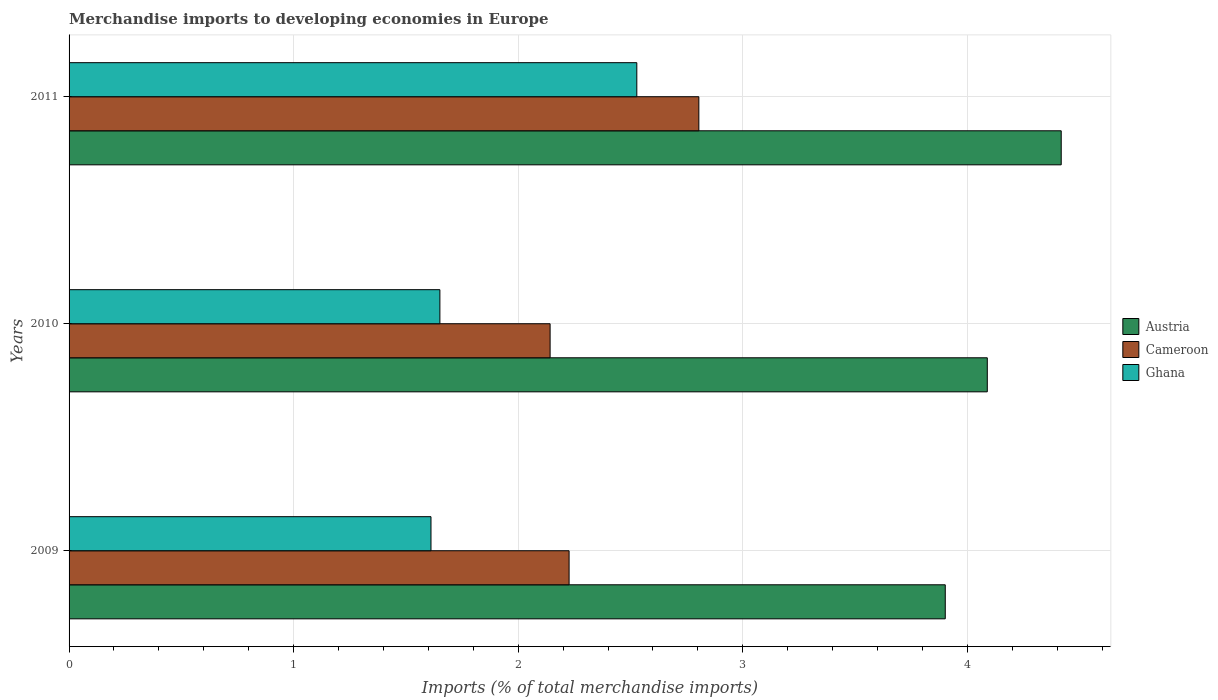How many groups of bars are there?
Provide a succinct answer. 3. Are the number of bars per tick equal to the number of legend labels?
Your answer should be compact. Yes. Are the number of bars on each tick of the Y-axis equal?
Give a very brief answer. Yes. How many bars are there on the 3rd tick from the top?
Your response must be concise. 3. How many bars are there on the 2nd tick from the bottom?
Provide a short and direct response. 3. In how many cases, is the number of bars for a given year not equal to the number of legend labels?
Provide a succinct answer. 0. What is the percentage total merchandise imports in Ghana in 2010?
Make the answer very short. 1.65. Across all years, what is the maximum percentage total merchandise imports in Austria?
Your answer should be compact. 4.42. Across all years, what is the minimum percentage total merchandise imports in Cameroon?
Give a very brief answer. 2.14. In which year was the percentage total merchandise imports in Ghana minimum?
Offer a terse response. 2009. What is the total percentage total merchandise imports in Cameroon in the graph?
Your response must be concise. 7.17. What is the difference between the percentage total merchandise imports in Cameroon in 2009 and that in 2010?
Provide a succinct answer. 0.08. What is the difference between the percentage total merchandise imports in Cameroon in 2009 and the percentage total merchandise imports in Ghana in 2011?
Provide a succinct answer. -0.3. What is the average percentage total merchandise imports in Cameroon per year?
Your answer should be compact. 2.39. In the year 2010, what is the difference between the percentage total merchandise imports in Ghana and percentage total merchandise imports in Cameroon?
Keep it short and to the point. -0.49. In how many years, is the percentage total merchandise imports in Ghana greater than 1.4 %?
Ensure brevity in your answer.  3. What is the ratio of the percentage total merchandise imports in Austria in 2010 to that in 2011?
Provide a short and direct response. 0.93. Is the percentage total merchandise imports in Austria in 2009 less than that in 2010?
Offer a very short reply. Yes. Is the difference between the percentage total merchandise imports in Ghana in 2009 and 2011 greater than the difference between the percentage total merchandise imports in Cameroon in 2009 and 2011?
Ensure brevity in your answer.  No. What is the difference between the highest and the second highest percentage total merchandise imports in Ghana?
Give a very brief answer. 0.88. What is the difference between the highest and the lowest percentage total merchandise imports in Ghana?
Your response must be concise. 0.92. In how many years, is the percentage total merchandise imports in Cameroon greater than the average percentage total merchandise imports in Cameroon taken over all years?
Your response must be concise. 1. Are all the bars in the graph horizontal?
Keep it short and to the point. Yes. How many years are there in the graph?
Your answer should be compact. 3. What is the difference between two consecutive major ticks on the X-axis?
Keep it short and to the point. 1. Are the values on the major ticks of X-axis written in scientific E-notation?
Your response must be concise. No. Does the graph contain any zero values?
Your response must be concise. No. Where does the legend appear in the graph?
Offer a terse response. Center right. How many legend labels are there?
Your response must be concise. 3. How are the legend labels stacked?
Your answer should be very brief. Vertical. What is the title of the graph?
Offer a terse response. Merchandise imports to developing economies in Europe. Does "Low income" appear as one of the legend labels in the graph?
Provide a succinct answer. No. What is the label or title of the X-axis?
Give a very brief answer. Imports (% of total merchandise imports). What is the Imports (% of total merchandise imports) in Austria in 2009?
Your answer should be very brief. 3.9. What is the Imports (% of total merchandise imports) of Cameroon in 2009?
Make the answer very short. 2.23. What is the Imports (% of total merchandise imports) in Ghana in 2009?
Give a very brief answer. 1.61. What is the Imports (% of total merchandise imports) of Austria in 2010?
Provide a short and direct response. 4.09. What is the Imports (% of total merchandise imports) of Cameroon in 2010?
Keep it short and to the point. 2.14. What is the Imports (% of total merchandise imports) in Ghana in 2010?
Provide a short and direct response. 1.65. What is the Imports (% of total merchandise imports) of Austria in 2011?
Give a very brief answer. 4.42. What is the Imports (% of total merchandise imports) of Cameroon in 2011?
Provide a succinct answer. 2.8. What is the Imports (% of total merchandise imports) of Ghana in 2011?
Offer a very short reply. 2.53. Across all years, what is the maximum Imports (% of total merchandise imports) of Austria?
Provide a short and direct response. 4.42. Across all years, what is the maximum Imports (% of total merchandise imports) of Cameroon?
Provide a succinct answer. 2.8. Across all years, what is the maximum Imports (% of total merchandise imports) of Ghana?
Make the answer very short. 2.53. Across all years, what is the minimum Imports (% of total merchandise imports) in Austria?
Your answer should be very brief. 3.9. Across all years, what is the minimum Imports (% of total merchandise imports) of Cameroon?
Make the answer very short. 2.14. Across all years, what is the minimum Imports (% of total merchandise imports) in Ghana?
Provide a short and direct response. 1.61. What is the total Imports (% of total merchandise imports) of Austria in the graph?
Your response must be concise. 12.41. What is the total Imports (% of total merchandise imports) of Cameroon in the graph?
Your response must be concise. 7.17. What is the total Imports (% of total merchandise imports) in Ghana in the graph?
Give a very brief answer. 5.79. What is the difference between the Imports (% of total merchandise imports) in Austria in 2009 and that in 2010?
Your answer should be very brief. -0.19. What is the difference between the Imports (% of total merchandise imports) of Cameroon in 2009 and that in 2010?
Offer a terse response. 0.08. What is the difference between the Imports (% of total merchandise imports) of Ghana in 2009 and that in 2010?
Offer a very short reply. -0.04. What is the difference between the Imports (% of total merchandise imports) of Austria in 2009 and that in 2011?
Provide a succinct answer. -0.52. What is the difference between the Imports (% of total merchandise imports) of Cameroon in 2009 and that in 2011?
Your answer should be compact. -0.58. What is the difference between the Imports (% of total merchandise imports) of Ghana in 2009 and that in 2011?
Offer a very short reply. -0.92. What is the difference between the Imports (% of total merchandise imports) in Austria in 2010 and that in 2011?
Offer a terse response. -0.33. What is the difference between the Imports (% of total merchandise imports) in Cameroon in 2010 and that in 2011?
Your answer should be compact. -0.66. What is the difference between the Imports (% of total merchandise imports) of Ghana in 2010 and that in 2011?
Make the answer very short. -0.88. What is the difference between the Imports (% of total merchandise imports) in Austria in 2009 and the Imports (% of total merchandise imports) in Cameroon in 2010?
Your response must be concise. 1.76. What is the difference between the Imports (% of total merchandise imports) of Austria in 2009 and the Imports (% of total merchandise imports) of Ghana in 2010?
Keep it short and to the point. 2.25. What is the difference between the Imports (% of total merchandise imports) of Cameroon in 2009 and the Imports (% of total merchandise imports) of Ghana in 2010?
Provide a succinct answer. 0.58. What is the difference between the Imports (% of total merchandise imports) in Austria in 2009 and the Imports (% of total merchandise imports) in Cameroon in 2011?
Offer a terse response. 1.1. What is the difference between the Imports (% of total merchandise imports) of Austria in 2009 and the Imports (% of total merchandise imports) of Ghana in 2011?
Provide a short and direct response. 1.37. What is the difference between the Imports (% of total merchandise imports) in Cameroon in 2009 and the Imports (% of total merchandise imports) in Ghana in 2011?
Give a very brief answer. -0.3. What is the difference between the Imports (% of total merchandise imports) of Austria in 2010 and the Imports (% of total merchandise imports) of Cameroon in 2011?
Offer a terse response. 1.28. What is the difference between the Imports (% of total merchandise imports) in Austria in 2010 and the Imports (% of total merchandise imports) in Ghana in 2011?
Make the answer very short. 1.56. What is the difference between the Imports (% of total merchandise imports) of Cameroon in 2010 and the Imports (% of total merchandise imports) of Ghana in 2011?
Your answer should be compact. -0.39. What is the average Imports (% of total merchandise imports) in Austria per year?
Give a very brief answer. 4.14. What is the average Imports (% of total merchandise imports) in Cameroon per year?
Give a very brief answer. 2.39. What is the average Imports (% of total merchandise imports) of Ghana per year?
Your answer should be compact. 1.93. In the year 2009, what is the difference between the Imports (% of total merchandise imports) in Austria and Imports (% of total merchandise imports) in Cameroon?
Give a very brief answer. 1.68. In the year 2009, what is the difference between the Imports (% of total merchandise imports) of Austria and Imports (% of total merchandise imports) of Ghana?
Give a very brief answer. 2.29. In the year 2009, what is the difference between the Imports (% of total merchandise imports) of Cameroon and Imports (% of total merchandise imports) of Ghana?
Make the answer very short. 0.61. In the year 2010, what is the difference between the Imports (% of total merchandise imports) in Austria and Imports (% of total merchandise imports) in Cameroon?
Ensure brevity in your answer.  1.95. In the year 2010, what is the difference between the Imports (% of total merchandise imports) in Austria and Imports (% of total merchandise imports) in Ghana?
Your answer should be very brief. 2.44. In the year 2010, what is the difference between the Imports (% of total merchandise imports) in Cameroon and Imports (% of total merchandise imports) in Ghana?
Your answer should be very brief. 0.49. In the year 2011, what is the difference between the Imports (% of total merchandise imports) of Austria and Imports (% of total merchandise imports) of Cameroon?
Offer a very short reply. 1.61. In the year 2011, what is the difference between the Imports (% of total merchandise imports) in Austria and Imports (% of total merchandise imports) in Ghana?
Your answer should be compact. 1.89. In the year 2011, what is the difference between the Imports (% of total merchandise imports) of Cameroon and Imports (% of total merchandise imports) of Ghana?
Make the answer very short. 0.28. What is the ratio of the Imports (% of total merchandise imports) of Austria in 2009 to that in 2010?
Make the answer very short. 0.95. What is the ratio of the Imports (% of total merchandise imports) in Cameroon in 2009 to that in 2010?
Your answer should be very brief. 1.04. What is the ratio of the Imports (% of total merchandise imports) of Ghana in 2009 to that in 2010?
Your answer should be compact. 0.98. What is the ratio of the Imports (% of total merchandise imports) in Austria in 2009 to that in 2011?
Your response must be concise. 0.88. What is the ratio of the Imports (% of total merchandise imports) of Cameroon in 2009 to that in 2011?
Offer a very short reply. 0.79. What is the ratio of the Imports (% of total merchandise imports) of Ghana in 2009 to that in 2011?
Your response must be concise. 0.64. What is the ratio of the Imports (% of total merchandise imports) of Austria in 2010 to that in 2011?
Offer a terse response. 0.93. What is the ratio of the Imports (% of total merchandise imports) of Cameroon in 2010 to that in 2011?
Your response must be concise. 0.76. What is the ratio of the Imports (% of total merchandise imports) of Ghana in 2010 to that in 2011?
Your response must be concise. 0.65. What is the difference between the highest and the second highest Imports (% of total merchandise imports) of Austria?
Provide a short and direct response. 0.33. What is the difference between the highest and the second highest Imports (% of total merchandise imports) in Cameroon?
Provide a short and direct response. 0.58. What is the difference between the highest and the second highest Imports (% of total merchandise imports) in Ghana?
Give a very brief answer. 0.88. What is the difference between the highest and the lowest Imports (% of total merchandise imports) in Austria?
Offer a terse response. 0.52. What is the difference between the highest and the lowest Imports (% of total merchandise imports) of Cameroon?
Provide a succinct answer. 0.66. What is the difference between the highest and the lowest Imports (% of total merchandise imports) of Ghana?
Give a very brief answer. 0.92. 